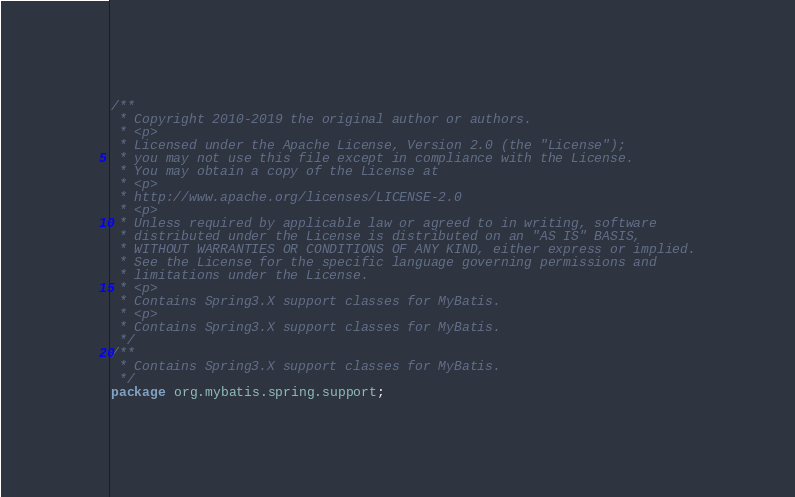Convert code to text. <code><loc_0><loc_0><loc_500><loc_500><_Java_>/**
 * Copyright 2010-2019 the original author or authors.
 * <p>
 * Licensed under the Apache License, Version 2.0 (the "License");
 * you may not use this file except in compliance with the License.
 * You may obtain a copy of the License at
 * <p>
 * http://www.apache.org/licenses/LICENSE-2.0
 * <p>
 * Unless required by applicable law or agreed to in writing, software
 * distributed under the License is distributed on an "AS IS" BASIS,
 * WITHOUT WARRANTIES OR CONDITIONS OF ANY KIND, either express or implied.
 * See the License for the specific language governing permissions and
 * limitations under the License.
 * <p>
 * Contains Spring3.X support classes for MyBatis.
 * <p>
 * Contains Spring3.X support classes for MyBatis.
 */
/**
 * Contains Spring3.X support classes for MyBatis.
 */
package org.mybatis.spring.support;
</code> 